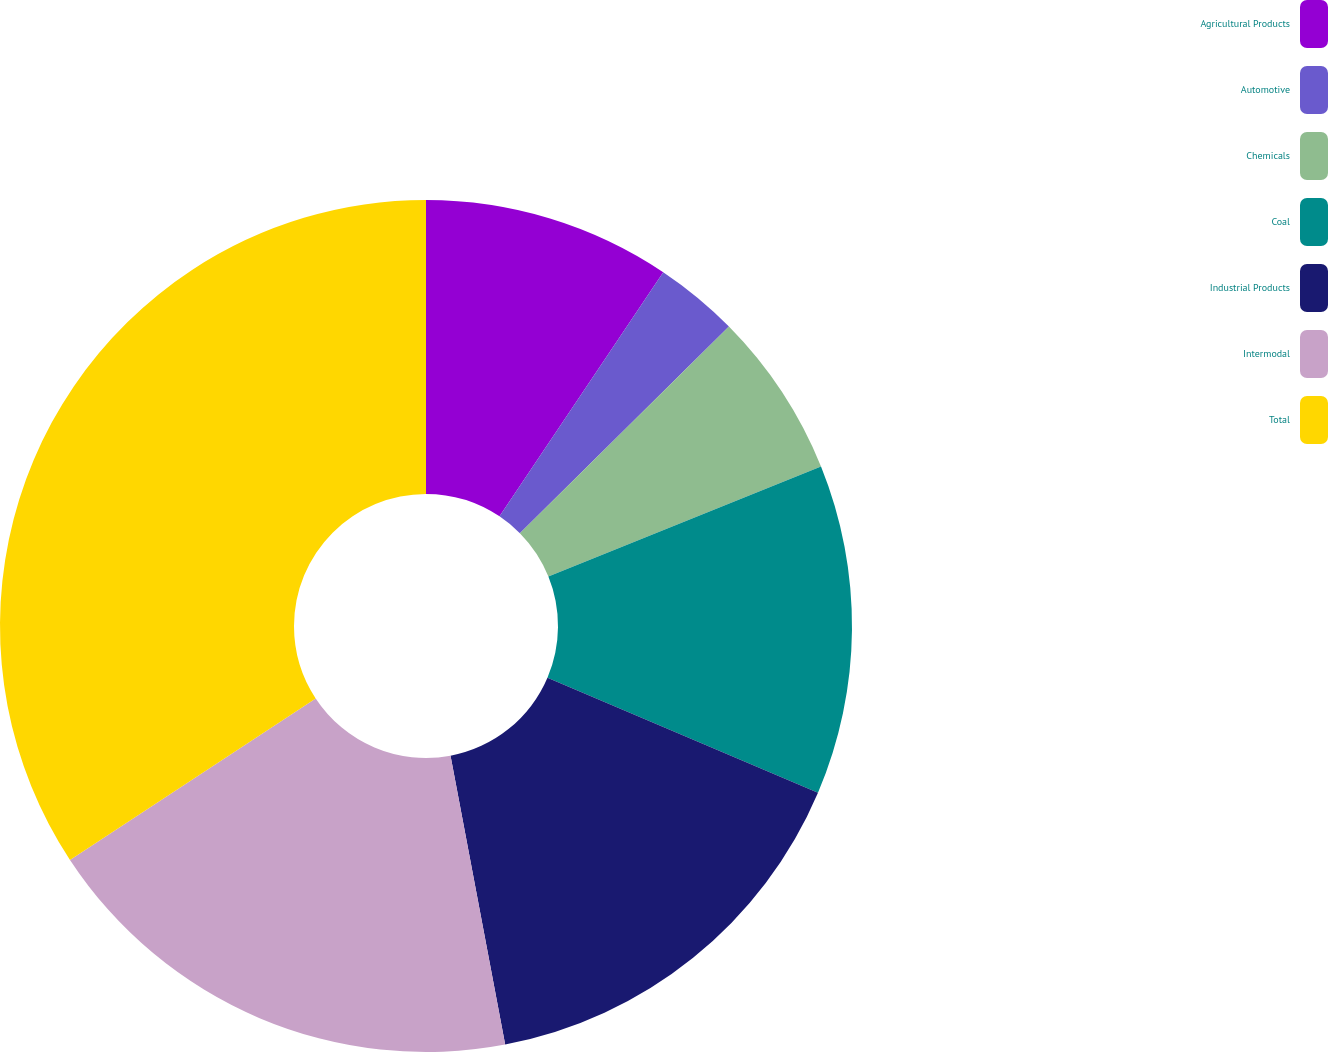Convert chart. <chart><loc_0><loc_0><loc_500><loc_500><pie_chart><fcel>Agricultural Products<fcel>Automotive<fcel>Chemicals<fcel>Coal<fcel>Industrial Products<fcel>Intermodal<fcel>Total<nl><fcel>9.4%<fcel>3.19%<fcel>6.3%<fcel>12.51%<fcel>15.62%<fcel>18.72%<fcel>34.25%<nl></chart> 